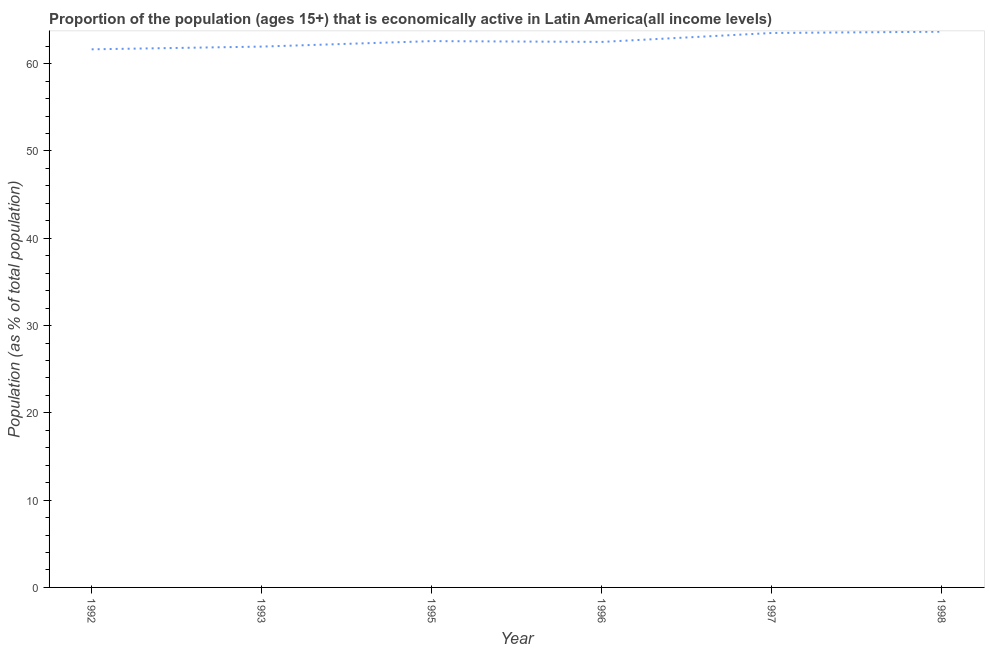What is the percentage of economically active population in 1996?
Make the answer very short. 62.49. Across all years, what is the maximum percentage of economically active population?
Your answer should be very brief. 63.66. Across all years, what is the minimum percentage of economically active population?
Provide a short and direct response. 61.65. In which year was the percentage of economically active population maximum?
Your response must be concise. 1998. In which year was the percentage of economically active population minimum?
Provide a short and direct response. 1992. What is the sum of the percentage of economically active population?
Your answer should be compact. 375.86. What is the difference between the percentage of economically active population in 1996 and 1997?
Your answer should be compact. -1.02. What is the average percentage of economically active population per year?
Your answer should be very brief. 62.64. What is the median percentage of economically active population?
Your answer should be compact. 62.54. In how many years, is the percentage of economically active population greater than 18 %?
Provide a succinct answer. 6. Do a majority of the years between 1998 and 1993 (inclusive) have percentage of economically active population greater than 6 %?
Offer a terse response. Yes. What is the ratio of the percentage of economically active population in 1993 to that in 1997?
Keep it short and to the point. 0.98. Is the difference between the percentage of economically active population in 1995 and 1997 greater than the difference between any two years?
Keep it short and to the point. No. What is the difference between the highest and the second highest percentage of economically active population?
Give a very brief answer. 0.15. What is the difference between the highest and the lowest percentage of economically active population?
Provide a succinct answer. 2.02. In how many years, is the percentage of economically active population greater than the average percentage of economically active population taken over all years?
Your answer should be very brief. 2. Does the percentage of economically active population monotonically increase over the years?
Your answer should be very brief. No. What is the difference between two consecutive major ticks on the Y-axis?
Provide a short and direct response. 10. Are the values on the major ticks of Y-axis written in scientific E-notation?
Keep it short and to the point. No. What is the title of the graph?
Your answer should be compact. Proportion of the population (ages 15+) that is economically active in Latin America(all income levels). What is the label or title of the X-axis?
Offer a terse response. Year. What is the label or title of the Y-axis?
Make the answer very short. Population (as % of total population). What is the Population (as % of total population) of 1992?
Offer a very short reply. 61.65. What is the Population (as % of total population) of 1993?
Offer a terse response. 61.96. What is the Population (as % of total population) of 1995?
Your answer should be compact. 62.58. What is the Population (as % of total population) of 1996?
Make the answer very short. 62.49. What is the Population (as % of total population) of 1997?
Give a very brief answer. 63.52. What is the Population (as % of total population) of 1998?
Your answer should be very brief. 63.66. What is the difference between the Population (as % of total population) in 1992 and 1993?
Your answer should be very brief. -0.31. What is the difference between the Population (as % of total population) in 1992 and 1995?
Your answer should be very brief. -0.94. What is the difference between the Population (as % of total population) in 1992 and 1996?
Make the answer very short. -0.85. What is the difference between the Population (as % of total population) in 1992 and 1997?
Keep it short and to the point. -1.87. What is the difference between the Population (as % of total population) in 1992 and 1998?
Your answer should be compact. -2.02. What is the difference between the Population (as % of total population) in 1993 and 1995?
Make the answer very short. -0.63. What is the difference between the Population (as % of total population) in 1993 and 1996?
Ensure brevity in your answer.  -0.54. What is the difference between the Population (as % of total population) in 1993 and 1997?
Your answer should be very brief. -1.56. What is the difference between the Population (as % of total population) in 1993 and 1998?
Your answer should be compact. -1.71. What is the difference between the Population (as % of total population) in 1995 and 1996?
Offer a terse response. 0.09. What is the difference between the Population (as % of total population) in 1995 and 1997?
Offer a terse response. -0.93. What is the difference between the Population (as % of total population) in 1995 and 1998?
Keep it short and to the point. -1.08. What is the difference between the Population (as % of total population) in 1996 and 1997?
Ensure brevity in your answer.  -1.02. What is the difference between the Population (as % of total population) in 1996 and 1998?
Provide a short and direct response. -1.17. What is the difference between the Population (as % of total population) in 1997 and 1998?
Your answer should be compact. -0.15. What is the ratio of the Population (as % of total population) in 1992 to that in 1996?
Offer a very short reply. 0.99. What is the ratio of the Population (as % of total population) in 1992 to that in 1997?
Your answer should be compact. 0.97. What is the ratio of the Population (as % of total population) in 1992 to that in 1998?
Keep it short and to the point. 0.97. What is the ratio of the Population (as % of total population) in 1993 to that in 1996?
Your answer should be very brief. 0.99. What is the ratio of the Population (as % of total population) in 1995 to that in 1997?
Make the answer very short. 0.98. What is the ratio of the Population (as % of total population) in 1996 to that in 1997?
Your answer should be very brief. 0.98. What is the ratio of the Population (as % of total population) in 1997 to that in 1998?
Provide a short and direct response. 1. 